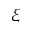<formula> <loc_0><loc_0><loc_500><loc_500>\xi</formula> 